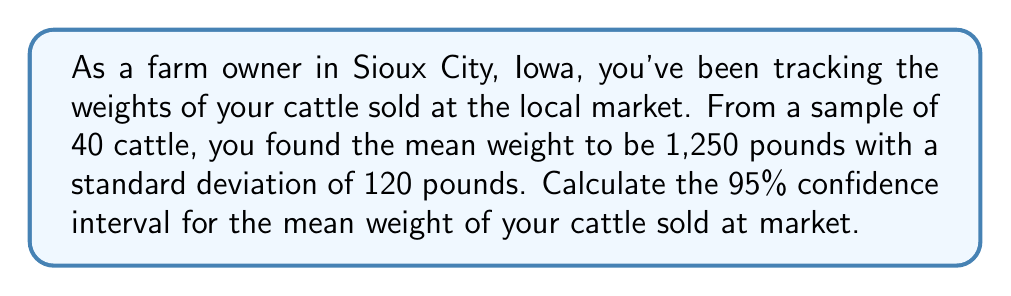Give your solution to this math problem. Let's follow these steps to calculate the confidence interval:

1. Identify the given information:
   - Sample size (n) = 40
   - Sample mean ($\bar{x}$) = 1,250 pounds
   - Sample standard deviation (s) = 120 pounds
   - Confidence level = 95%

2. Determine the critical value:
   For a 95% confidence level and n-1 = 39 degrees of freedom, the t-critical value is approximately 2.023 (from t-distribution table).

3. Calculate the standard error of the mean:
   $SE = \frac{s}{\sqrt{n}} = \frac{120}{\sqrt{40}} = 18.97$

4. Calculate the margin of error:
   $ME = t_{critical} \times SE = 2.023 \times 18.97 = 38.37$

5. Calculate the confidence interval:
   Lower bound: $\bar{x} - ME = 1250 - 38.37 = 1211.63$
   Upper bound: $\bar{x} + ME = 1250 + 38.37 = 1288.37$

Therefore, the 95% confidence interval for the mean weight of your cattle sold at market is (1211.63, 1288.37) pounds.
Answer: (1211.63, 1288.37) pounds 